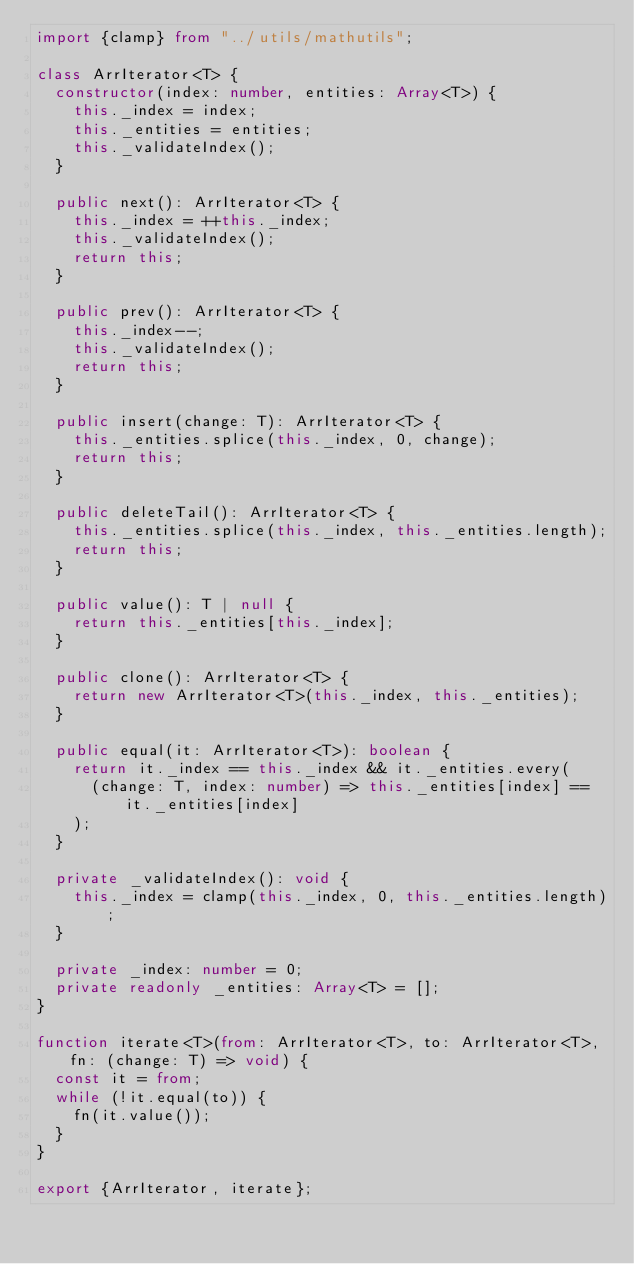<code> <loc_0><loc_0><loc_500><loc_500><_TypeScript_>import {clamp} from "../utils/mathutils";

class ArrIterator<T> {
	constructor(index: number, entities: Array<T>) {
		this._index = index;
		this._entities = entities;
		this._validateIndex();
	}

	public next(): ArrIterator<T> {
		this._index = ++this._index;
		this._validateIndex();
		return this;
	}

	public prev(): ArrIterator<T> {
		this._index--;
		this._validateIndex();
		return this;
	}

	public insert(change: T): ArrIterator<T> {
		this._entities.splice(this._index, 0, change);
		return this;
	}

	public deleteTail(): ArrIterator<T> {
		this._entities.splice(this._index, this._entities.length);
		return this;
	}

	public value(): T | null {
		return this._entities[this._index];
	}

	public clone(): ArrIterator<T> {
		return new ArrIterator<T>(this._index, this._entities);
	}

	public equal(it: ArrIterator<T>): boolean {
		return it._index == this._index && it._entities.every(
			(change: T, index: number) => this._entities[index] == it._entities[index]
		);
	}

	private _validateIndex(): void {
		this._index = clamp(this._index, 0, this._entities.length);
	}

	private _index: number = 0;
	private readonly _entities: Array<T> = [];
}

function iterate<T>(from: ArrIterator<T>, to: ArrIterator<T>, fn: (change: T) => void) {
	const it = from;
	while (!it.equal(to)) {
		fn(it.value());
	}
}

export {ArrIterator, iterate};</code> 